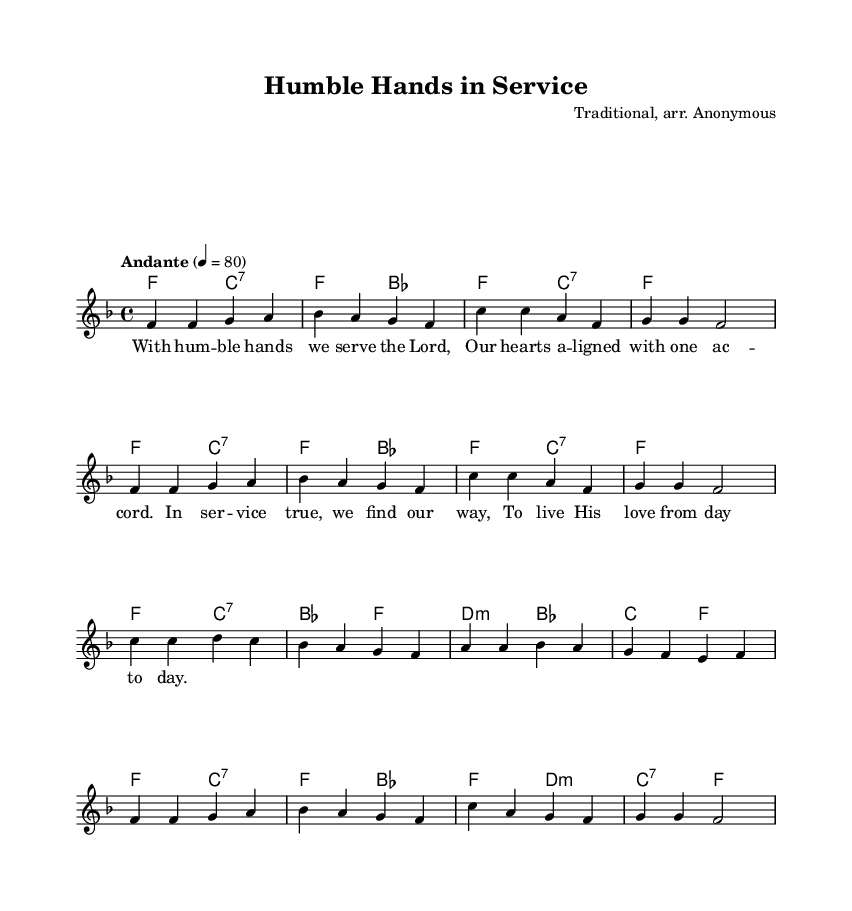What is the key signature of this music? The key signature is F major, which has one flat (B flat). This can be determined from the beginning of the score where the key is indicated.
Answer: F major What is the time signature of this music? The time signature is 4/4, which indicates there are four beats in each measure and each beat is a quarter note. This is shown at the start of the score.
Answer: 4/4 What is the tempo marking of this music? The tempo marking is Andante, with a tempo of 80 quarter notes per minute. This is stated above the music staff as an indication of how fast the piece should be played.
Answer: Andante How many measures are there in the melody? There are 12 measures in the melody section, which can be counted by looking at the number of vertical lines (bar lines) in the music.
Answer: 12 Which phrase emphasizes service and humility in the lyrics? The phrase "With humble hands we serve the Lord" emphasizes service and humility, as it expresses the act of serving God with humility. This can be identified by reading through the lyrics provided under the melody.
Answer: With humble hands we serve the Lord What type of chords are used in the second half of the piece? The second half of the piece primarily uses major and minor chords, as indicated by the chord symbols in the chord section below the staff. A closer look reveals a sequence of F major, C7, and B flat major chords.
Answer: Major and minor chords In which section is the hymn most reflective of religious themes? The section that reflects religious themes is found in the lyrics, particularly in "To live His love from day to day," highlighting the dedication to living out faith through service. This insight comes from analyzing the message conveyed in the lyrical content.
Answer: To live His love from day to day 